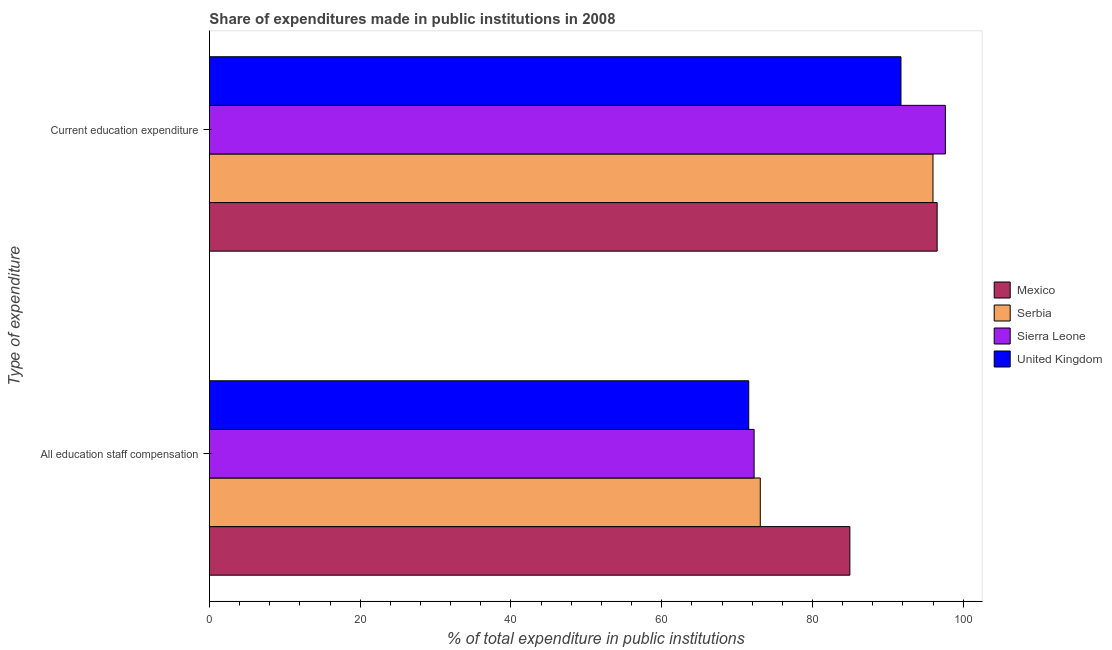How many groups of bars are there?
Offer a terse response. 2. Are the number of bars per tick equal to the number of legend labels?
Offer a terse response. Yes. What is the label of the 1st group of bars from the top?
Give a very brief answer. Current education expenditure. What is the expenditure in staff compensation in Sierra Leone?
Offer a very short reply. 72.25. Across all countries, what is the maximum expenditure in education?
Your answer should be very brief. 97.62. Across all countries, what is the minimum expenditure in education?
Provide a short and direct response. 91.73. What is the total expenditure in education in the graph?
Provide a short and direct response. 381.87. What is the difference between the expenditure in staff compensation in Mexico and that in Serbia?
Ensure brevity in your answer.  11.88. What is the difference between the expenditure in staff compensation in Mexico and the expenditure in education in Serbia?
Give a very brief answer. -11.03. What is the average expenditure in education per country?
Provide a short and direct response. 95.47. What is the difference between the expenditure in education and expenditure in staff compensation in Mexico?
Provide a succinct answer. 11.58. What is the ratio of the expenditure in education in Mexico to that in United Kingdom?
Provide a short and direct response. 1.05. Is the expenditure in staff compensation in Sierra Leone less than that in United Kingdom?
Offer a terse response. No. What does the 2nd bar from the top in Current education expenditure represents?
Give a very brief answer. Sierra Leone. What does the 2nd bar from the bottom in All education staff compensation represents?
Offer a terse response. Serbia. How many bars are there?
Make the answer very short. 8. Are all the bars in the graph horizontal?
Make the answer very short. Yes. How many countries are there in the graph?
Ensure brevity in your answer.  4. What is the difference between two consecutive major ticks on the X-axis?
Offer a terse response. 20. Does the graph contain any zero values?
Ensure brevity in your answer.  No. How many legend labels are there?
Provide a short and direct response. 4. How are the legend labels stacked?
Keep it short and to the point. Vertical. What is the title of the graph?
Make the answer very short. Share of expenditures made in public institutions in 2008. Does "Congo (Republic)" appear as one of the legend labels in the graph?
Make the answer very short. No. What is the label or title of the X-axis?
Your response must be concise. % of total expenditure in public institutions. What is the label or title of the Y-axis?
Your answer should be compact. Type of expenditure. What is the % of total expenditure in public institutions of Mexico in All education staff compensation?
Ensure brevity in your answer.  84.95. What is the % of total expenditure in public institutions in Serbia in All education staff compensation?
Your answer should be compact. 73.07. What is the % of total expenditure in public institutions in Sierra Leone in All education staff compensation?
Make the answer very short. 72.25. What is the % of total expenditure in public institutions in United Kingdom in All education staff compensation?
Provide a succinct answer. 71.54. What is the % of total expenditure in public institutions of Mexico in Current education expenditure?
Your answer should be compact. 96.53. What is the % of total expenditure in public institutions of Serbia in Current education expenditure?
Your answer should be very brief. 95.98. What is the % of total expenditure in public institutions in Sierra Leone in Current education expenditure?
Offer a terse response. 97.62. What is the % of total expenditure in public institutions of United Kingdom in Current education expenditure?
Keep it short and to the point. 91.73. Across all Type of expenditure, what is the maximum % of total expenditure in public institutions of Mexico?
Offer a very short reply. 96.53. Across all Type of expenditure, what is the maximum % of total expenditure in public institutions in Serbia?
Provide a short and direct response. 95.98. Across all Type of expenditure, what is the maximum % of total expenditure in public institutions in Sierra Leone?
Ensure brevity in your answer.  97.62. Across all Type of expenditure, what is the maximum % of total expenditure in public institutions of United Kingdom?
Keep it short and to the point. 91.73. Across all Type of expenditure, what is the minimum % of total expenditure in public institutions in Mexico?
Ensure brevity in your answer.  84.95. Across all Type of expenditure, what is the minimum % of total expenditure in public institutions in Serbia?
Give a very brief answer. 73.07. Across all Type of expenditure, what is the minimum % of total expenditure in public institutions in Sierra Leone?
Your answer should be very brief. 72.25. Across all Type of expenditure, what is the minimum % of total expenditure in public institutions of United Kingdom?
Ensure brevity in your answer.  71.54. What is the total % of total expenditure in public institutions of Mexico in the graph?
Offer a terse response. 181.49. What is the total % of total expenditure in public institutions in Serbia in the graph?
Your answer should be very brief. 169.05. What is the total % of total expenditure in public institutions of Sierra Leone in the graph?
Offer a terse response. 169.88. What is the total % of total expenditure in public institutions in United Kingdom in the graph?
Keep it short and to the point. 163.27. What is the difference between the % of total expenditure in public institutions in Mexico in All education staff compensation and that in Current education expenditure?
Offer a terse response. -11.58. What is the difference between the % of total expenditure in public institutions in Serbia in All education staff compensation and that in Current education expenditure?
Offer a very short reply. -22.91. What is the difference between the % of total expenditure in public institutions of Sierra Leone in All education staff compensation and that in Current education expenditure?
Your answer should be compact. -25.37. What is the difference between the % of total expenditure in public institutions of United Kingdom in All education staff compensation and that in Current education expenditure?
Make the answer very short. -20.19. What is the difference between the % of total expenditure in public institutions of Mexico in All education staff compensation and the % of total expenditure in public institutions of Serbia in Current education expenditure?
Ensure brevity in your answer.  -11.03. What is the difference between the % of total expenditure in public institutions of Mexico in All education staff compensation and the % of total expenditure in public institutions of Sierra Leone in Current education expenditure?
Give a very brief answer. -12.67. What is the difference between the % of total expenditure in public institutions in Mexico in All education staff compensation and the % of total expenditure in public institutions in United Kingdom in Current education expenditure?
Offer a very short reply. -6.78. What is the difference between the % of total expenditure in public institutions of Serbia in All education staff compensation and the % of total expenditure in public institutions of Sierra Leone in Current education expenditure?
Your response must be concise. -24.55. What is the difference between the % of total expenditure in public institutions in Serbia in All education staff compensation and the % of total expenditure in public institutions in United Kingdom in Current education expenditure?
Keep it short and to the point. -18.66. What is the difference between the % of total expenditure in public institutions of Sierra Leone in All education staff compensation and the % of total expenditure in public institutions of United Kingdom in Current education expenditure?
Your response must be concise. -19.48. What is the average % of total expenditure in public institutions in Mexico per Type of expenditure?
Keep it short and to the point. 90.74. What is the average % of total expenditure in public institutions in Serbia per Type of expenditure?
Your response must be concise. 84.53. What is the average % of total expenditure in public institutions in Sierra Leone per Type of expenditure?
Your answer should be very brief. 84.94. What is the average % of total expenditure in public institutions of United Kingdom per Type of expenditure?
Ensure brevity in your answer.  81.64. What is the difference between the % of total expenditure in public institutions of Mexico and % of total expenditure in public institutions of Serbia in All education staff compensation?
Give a very brief answer. 11.88. What is the difference between the % of total expenditure in public institutions in Mexico and % of total expenditure in public institutions in Sierra Leone in All education staff compensation?
Provide a short and direct response. 12.7. What is the difference between the % of total expenditure in public institutions of Mexico and % of total expenditure in public institutions of United Kingdom in All education staff compensation?
Ensure brevity in your answer.  13.41. What is the difference between the % of total expenditure in public institutions in Serbia and % of total expenditure in public institutions in Sierra Leone in All education staff compensation?
Your response must be concise. 0.82. What is the difference between the % of total expenditure in public institutions of Serbia and % of total expenditure in public institutions of United Kingdom in All education staff compensation?
Your response must be concise. 1.53. What is the difference between the % of total expenditure in public institutions of Sierra Leone and % of total expenditure in public institutions of United Kingdom in All education staff compensation?
Keep it short and to the point. 0.71. What is the difference between the % of total expenditure in public institutions in Mexico and % of total expenditure in public institutions in Serbia in Current education expenditure?
Offer a very short reply. 0.55. What is the difference between the % of total expenditure in public institutions of Mexico and % of total expenditure in public institutions of Sierra Leone in Current education expenditure?
Ensure brevity in your answer.  -1.09. What is the difference between the % of total expenditure in public institutions of Mexico and % of total expenditure in public institutions of United Kingdom in Current education expenditure?
Give a very brief answer. 4.8. What is the difference between the % of total expenditure in public institutions of Serbia and % of total expenditure in public institutions of Sierra Leone in Current education expenditure?
Give a very brief answer. -1.64. What is the difference between the % of total expenditure in public institutions of Serbia and % of total expenditure in public institutions of United Kingdom in Current education expenditure?
Provide a short and direct response. 4.25. What is the difference between the % of total expenditure in public institutions of Sierra Leone and % of total expenditure in public institutions of United Kingdom in Current education expenditure?
Give a very brief answer. 5.89. What is the ratio of the % of total expenditure in public institutions in Mexico in All education staff compensation to that in Current education expenditure?
Give a very brief answer. 0.88. What is the ratio of the % of total expenditure in public institutions of Serbia in All education staff compensation to that in Current education expenditure?
Your answer should be very brief. 0.76. What is the ratio of the % of total expenditure in public institutions in Sierra Leone in All education staff compensation to that in Current education expenditure?
Your answer should be compact. 0.74. What is the ratio of the % of total expenditure in public institutions in United Kingdom in All education staff compensation to that in Current education expenditure?
Offer a terse response. 0.78. What is the difference between the highest and the second highest % of total expenditure in public institutions of Mexico?
Ensure brevity in your answer.  11.58. What is the difference between the highest and the second highest % of total expenditure in public institutions of Serbia?
Your answer should be very brief. 22.91. What is the difference between the highest and the second highest % of total expenditure in public institutions of Sierra Leone?
Your answer should be very brief. 25.37. What is the difference between the highest and the second highest % of total expenditure in public institutions in United Kingdom?
Keep it short and to the point. 20.19. What is the difference between the highest and the lowest % of total expenditure in public institutions in Mexico?
Offer a terse response. 11.58. What is the difference between the highest and the lowest % of total expenditure in public institutions in Serbia?
Provide a short and direct response. 22.91. What is the difference between the highest and the lowest % of total expenditure in public institutions of Sierra Leone?
Keep it short and to the point. 25.37. What is the difference between the highest and the lowest % of total expenditure in public institutions in United Kingdom?
Keep it short and to the point. 20.19. 